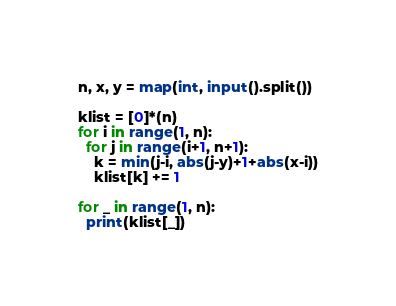Convert code to text. <code><loc_0><loc_0><loc_500><loc_500><_Python_>n, x, y = map(int, input().split())

klist = [0]*(n)
for i in range(1, n):
  for j in range(i+1, n+1):
    k = min(j-i, abs(j-y)+1+abs(x-i))
    klist[k] += 1

for _ in range(1, n):
  print(klist[_])</code> 